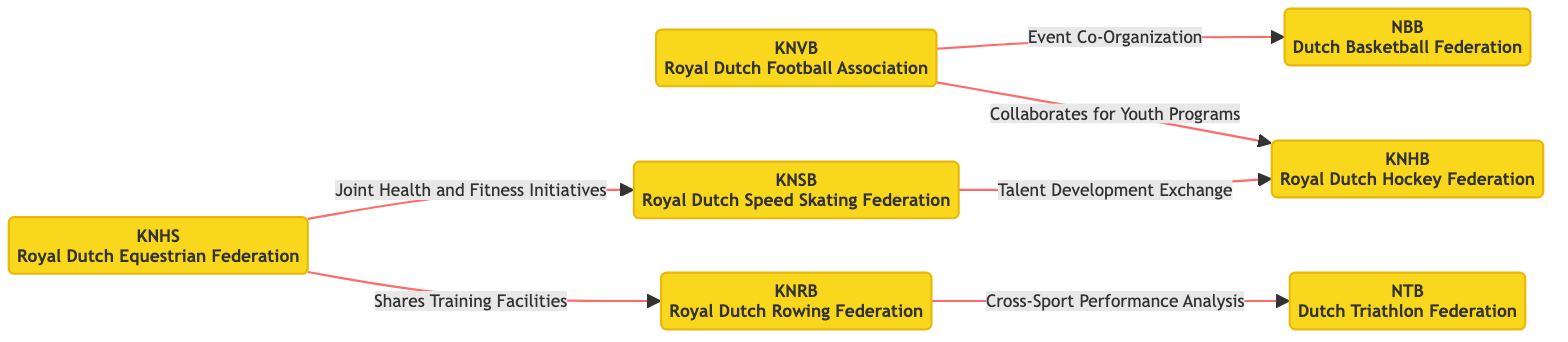What is the total number of associations in the diagram? The diagram lists seven Dutch sporting associations: Royal Dutch Football Association, Royal Dutch Equestrian Federation, Royal Dutch Speed Skating Federation, Royal Dutch Hockey Federation, Dutch Triathlon Federation, Royal Dutch Rowing Federation, and Dutch Basketball Federation. Counting these provides the total.
Answer: 7 Which two associations collaborate for youth programs? The edge labeled "Collaborates for Youth Programs" connects the Royal Dutch Football Association (KNVB) and the Royal Dutch Hockey Federation (KNHB). Therefore, these two associations collaborate in this area.
Answer: Royal Dutch Football Association and Royal Dutch Hockey Federation How many edges are there in the diagram? The diagram shows six connections (edges) that link the various associations. By counting each of the lines connecting nodes, we can determine the total number of edges.
Answer: 6 What type of initiatives do the Royal Dutch Equestrian Federation and the Royal Dutch Speed Skating Federation share? The edge labeled "Joint Health and Fitness Initiatives" indicates that the Royal Dutch Equestrian Federation (KNHS) and the Royal Dutch Speed Skating Federation (KNSB) share initiatives related to health and fitness.
Answer: Joint Health and Fitness Initiatives Which federation collaborates with the Dutch Triathlon Federation for performance analysis? The edge labeled "Cross-Sport Performance Analysis" shows the Royal Dutch Rowing Federation (KNRB) collaborating with the Dutch Triathlon Federation (NTB). Hence, the KNRB works with NTB for this purpose.
Answer: Royal Dutch Rowing Federation What is the relationship between the Royal Dutch Speed Skating Federation and the Royal Dutch Hockey Federation? The edge labeled "Talent Development Exchange" indicates that the Royal Dutch Speed Skating Federation (KNSB) engages with the Royal Dutch Hockey Federation (KNHB) for talent development, representing a collaborative effort in this area.
Answer: Talent Development Exchange Which two federations are involved in event co-organization? The edge labeled "Event Co-Organization" connects the Royal Dutch Football Association (KNVB) with the Dutch Basketball Federation (NBB), indicating their involvement in organizing events together.
Answer: Royal Dutch Football Association and Dutch Basketball Federation 